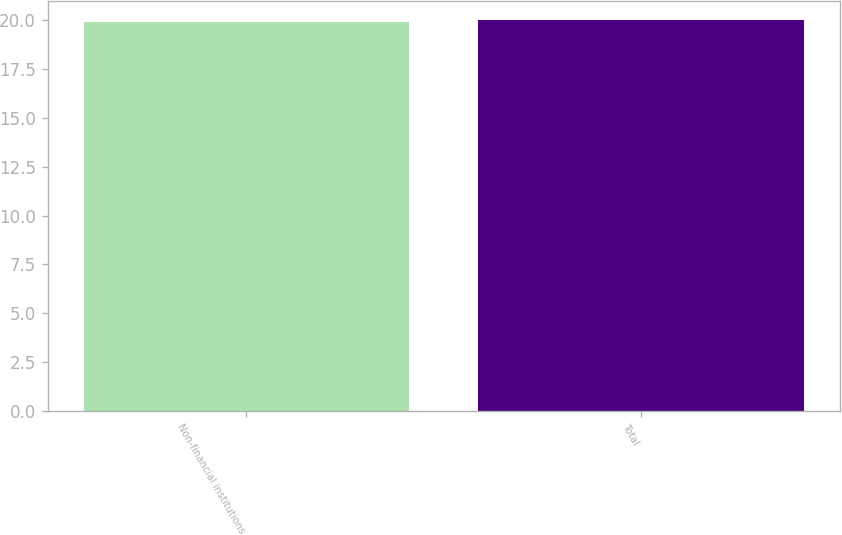Convert chart to OTSL. <chart><loc_0><loc_0><loc_500><loc_500><bar_chart><fcel>Non-financial institutions<fcel>Total<nl><fcel>19.9<fcel>20<nl></chart> 